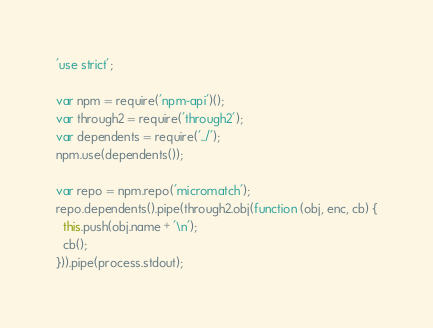Convert code to text. <code><loc_0><loc_0><loc_500><loc_500><_JavaScript_>'use strict';

var npm = require('npm-api')();
var through2 = require('through2');
var dependents = require('../');
npm.use(dependents());

var repo = npm.repo('micromatch');
repo.dependents().pipe(through2.obj(function (obj, enc, cb) {
  this.push(obj.name + '\n');
  cb();
})).pipe(process.stdout);
</code> 